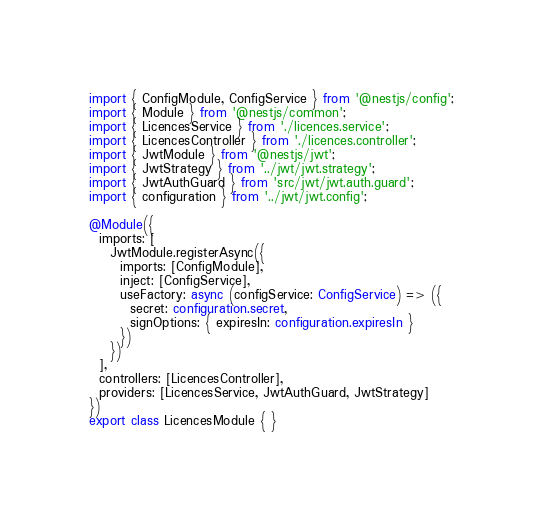<code> <loc_0><loc_0><loc_500><loc_500><_TypeScript_>import { ConfigModule, ConfigService } from '@nestjs/config';
import { Module } from '@nestjs/common';
import { LicencesService } from './licences.service';
import { LicencesController } from './licences.controller';
import { JwtModule } from '@nestjs/jwt';
import { JwtStrategy } from '../jwt/jwt.strategy';
import { JwtAuthGuard } from 'src/jwt/jwt.auth.guard';
import { configuration } from '../jwt/jwt.config';

@Module({
  imports: [
    JwtModule.registerAsync({
      imports: [ConfigModule],
      inject: [ConfigService],
      useFactory: async (configService: ConfigService) => ({
        secret: configuration.secret,
        signOptions: { expiresIn: configuration.expiresIn }
      })
    })
  ],
  controllers: [LicencesController],
  providers: [LicencesService, JwtAuthGuard, JwtStrategy]
})
export class LicencesModule { }
</code> 